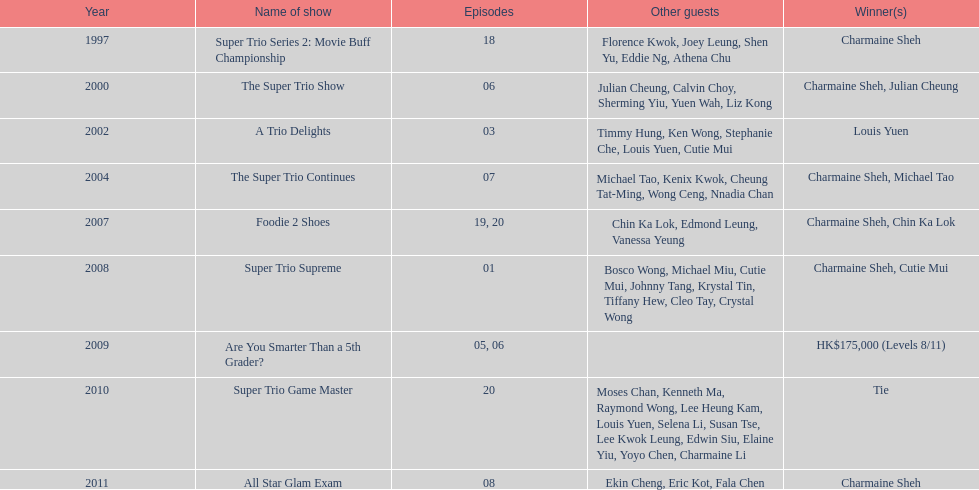Before appearing on another variety show, how many continuous trio shows did charmaine sheh perform in? 34. Could you parse the entire table as a dict? {'header': ['Year', 'Name of show', 'Episodes', 'Other guests', 'Winner(s)'], 'rows': [['1997', 'Super Trio Series 2: Movie Buff Championship', '18', 'Florence Kwok, Joey Leung, Shen Yu, Eddie Ng, Athena Chu', 'Charmaine Sheh'], ['2000', 'The Super Trio Show', '06', 'Julian Cheung, Calvin Choy, Sherming Yiu, Yuen Wah, Liz Kong', 'Charmaine Sheh, Julian Cheung'], ['2002', 'A Trio Delights', '03', 'Timmy Hung, Ken Wong, Stephanie Che, Louis Yuen, Cutie Mui', 'Louis Yuen'], ['2004', 'The Super Trio Continues', '07', 'Michael Tao, Kenix Kwok, Cheung Tat-Ming, Wong Ceng, Nnadia Chan', 'Charmaine Sheh, Michael Tao'], ['2007', 'Foodie 2 Shoes', '19, 20', 'Chin Ka Lok, Edmond Leung, Vanessa Yeung', 'Charmaine Sheh, Chin Ka Lok'], ['2008', 'Super Trio Supreme', '01', 'Bosco Wong, Michael Miu, Cutie Mui, Johnny Tang, Krystal Tin, Tiffany Hew, Cleo Tay, Crystal Wong', 'Charmaine Sheh, Cutie Mui'], ['2009', 'Are You Smarter Than a 5th Grader?', '05, 06', '', 'HK$175,000 (Levels 8/11)'], ['2010', 'Super Trio Game Master', '20', 'Moses Chan, Kenneth Ma, Raymond Wong, Lee Heung Kam, Louis Yuen, Selena Li, Susan Tse, Lee Kwok Leung, Edwin Siu, Elaine Yiu, Yoyo Chen, Charmaine Li', 'Tie'], ['2011', 'All Star Glam Exam', '08', 'Ekin Cheng, Eric Kot, Fala Chen', 'Charmaine Sheh']]} 